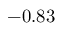Convert formula to latex. <formula><loc_0><loc_0><loc_500><loc_500>- 0 . 8 3</formula> 